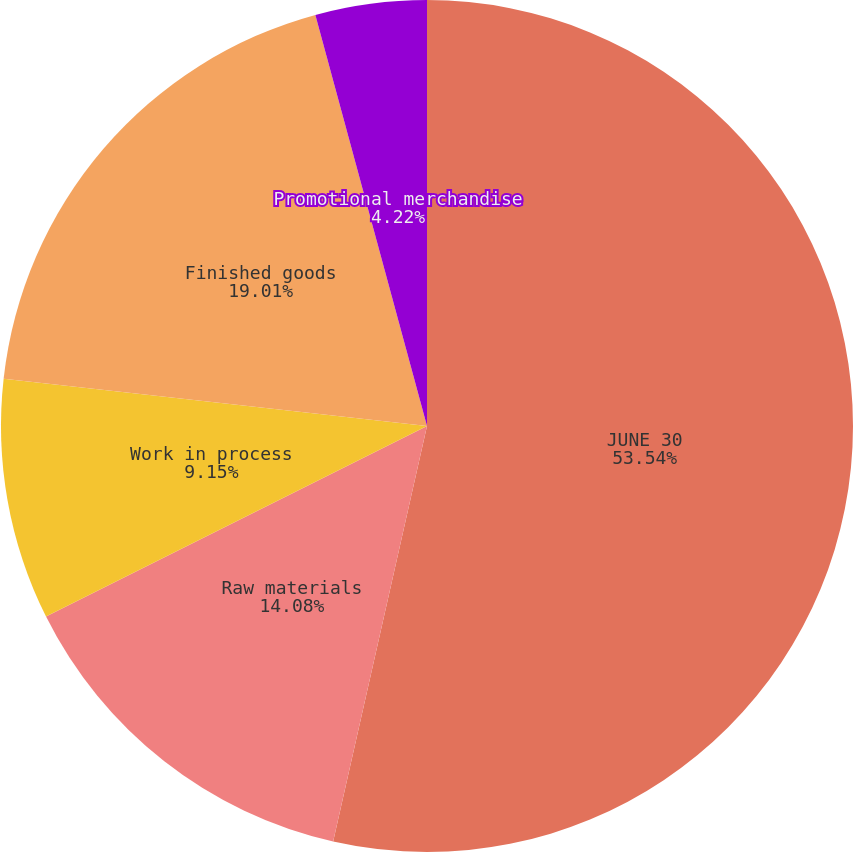Convert chart. <chart><loc_0><loc_0><loc_500><loc_500><pie_chart><fcel>JUNE 30<fcel>Raw materials<fcel>Work in process<fcel>Finished goods<fcel>Promotional merchandise<nl><fcel>53.53%<fcel>14.08%<fcel>9.15%<fcel>19.01%<fcel>4.22%<nl></chart> 